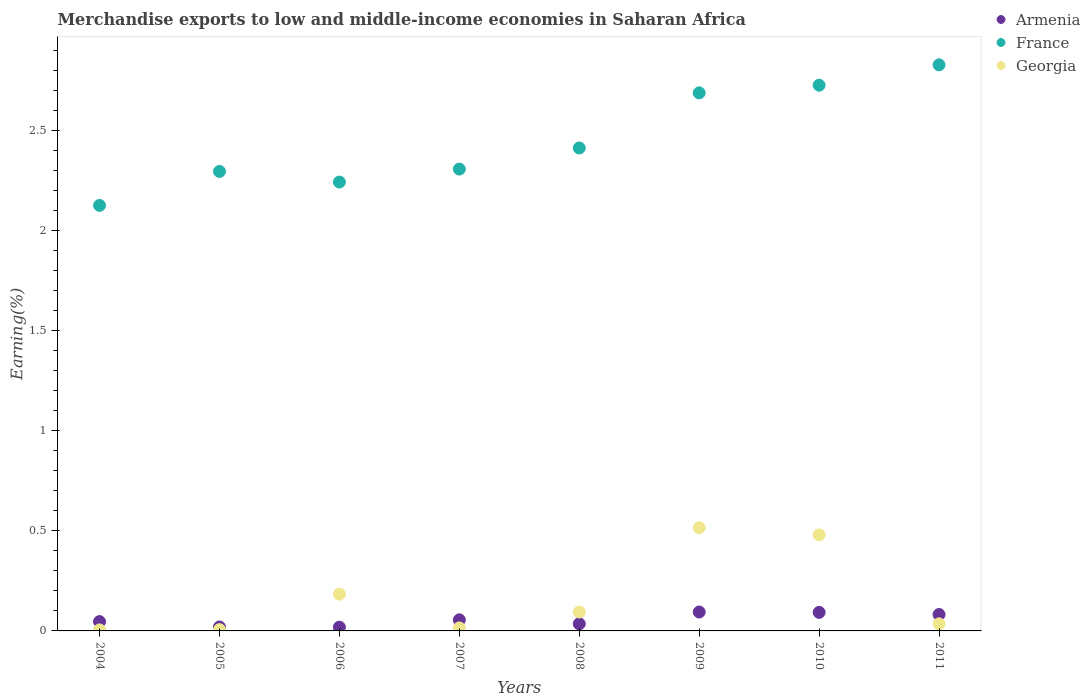Is the number of dotlines equal to the number of legend labels?
Provide a short and direct response. Yes. What is the percentage of amount earned from merchandise exports in Armenia in 2004?
Keep it short and to the point. 0.05. Across all years, what is the maximum percentage of amount earned from merchandise exports in Armenia?
Offer a very short reply. 0.09. Across all years, what is the minimum percentage of amount earned from merchandise exports in France?
Ensure brevity in your answer.  2.13. In which year was the percentage of amount earned from merchandise exports in Armenia minimum?
Make the answer very short. 2006. What is the total percentage of amount earned from merchandise exports in Georgia in the graph?
Your answer should be compact. 1.34. What is the difference between the percentage of amount earned from merchandise exports in Armenia in 2006 and that in 2011?
Ensure brevity in your answer.  -0.06. What is the difference between the percentage of amount earned from merchandise exports in Georgia in 2005 and the percentage of amount earned from merchandise exports in France in 2008?
Offer a very short reply. -2.41. What is the average percentage of amount earned from merchandise exports in Georgia per year?
Your answer should be very brief. 0.17. In the year 2007, what is the difference between the percentage of amount earned from merchandise exports in France and percentage of amount earned from merchandise exports in Armenia?
Offer a terse response. 2.25. What is the ratio of the percentage of amount earned from merchandise exports in Armenia in 2008 to that in 2009?
Ensure brevity in your answer.  0.38. Is the difference between the percentage of amount earned from merchandise exports in France in 2005 and 2011 greater than the difference between the percentage of amount earned from merchandise exports in Armenia in 2005 and 2011?
Offer a terse response. No. What is the difference between the highest and the second highest percentage of amount earned from merchandise exports in Armenia?
Offer a terse response. 0. What is the difference between the highest and the lowest percentage of amount earned from merchandise exports in Georgia?
Make the answer very short. 0.51. In how many years, is the percentage of amount earned from merchandise exports in France greater than the average percentage of amount earned from merchandise exports in France taken over all years?
Provide a short and direct response. 3. Is it the case that in every year, the sum of the percentage of amount earned from merchandise exports in France and percentage of amount earned from merchandise exports in Georgia  is greater than the percentage of amount earned from merchandise exports in Armenia?
Your answer should be compact. Yes. Does the percentage of amount earned from merchandise exports in Georgia monotonically increase over the years?
Offer a very short reply. No. Is the percentage of amount earned from merchandise exports in Armenia strictly less than the percentage of amount earned from merchandise exports in France over the years?
Ensure brevity in your answer.  Yes. Are the values on the major ticks of Y-axis written in scientific E-notation?
Your response must be concise. No. Does the graph contain any zero values?
Offer a terse response. No. How are the legend labels stacked?
Give a very brief answer. Vertical. What is the title of the graph?
Ensure brevity in your answer.  Merchandise exports to low and middle-income economies in Saharan Africa. What is the label or title of the Y-axis?
Offer a very short reply. Earning(%). What is the Earning(%) of Armenia in 2004?
Keep it short and to the point. 0.05. What is the Earning(%) of France in 2004?
Make the answer very short. 2.13. What is the Earning(%) of Georgia in 2004?
Your answer should be very brief. 0.01. What is the Earning(%) in Armenia in 2005?
Your response must be concise. 0.02. What is the Earning(%) in France in 2005?
Give a very brief answer. 2.3. What is the Earning(%) in Georgia in 2005?
Your response must be concise. 0.01. What is the Earning(%) in Armenia in 2006?
Ensure brevity in your answer.  0.02. What is the Earning(%) in France in 2006?
Give a very brief answer. 2.24. What is the Earning(%) of Georgia in 2006?
Your response must be concise. 0.18. What is the Earning(%) of Armenia in 2007?
Give a very brief answer. 0.06. What is the Earning(%) of France in 2007?
Offer a terse response. 2.31. What is the Earning(%) of Georgia in 2007?
Keep it short and to the point. 0.02. What is the Earning(%) of Armenia in 2008?
Give a very brief answer. 0.04. What is the Earning(%) in France in 2008?
Offer a terse response. 2.41. What is the Earning(%) of Georgia in 2008?
Provide a short and direct response. 0.09. What is the Earning(%) of Armenia in 2009?
Offer a terse response. 0.09. What is the Earning(%) of France in 2009?
Ensure brevity in your answer.  2.69. What is the Earning(%) in Georgia in 2009?
Your answer should be compact. 0.52. What is the Earning(%) of Armenia in 2010?
Provide a succinct answer. 0.09. What is the Earning(%) of France in 2010?
Offer a very short reply. 2.73. What is the Earning(%) of Georgia in 2010?
Offer a very short reply. 0.48. What is the Earning(%) of Armenia in 2011?
Offer a very short reply. 0.08. What is the Earning(%) of France in 2011?
Offer a terse response. 2.83. What is the Earning(%) of Georgia in 2011?
Your answer should be very brief. 0.04. Across all years, what is the maximum Earning(%) in Armenia?
Make the answer very short. 0.09. Across all years, what is the maximum Earning(%) in France?
Your answer should be very brief. 2.83. Across all years, what is the maximum Earning(%) in Georgia?
Offer a terse response. 0.52. Across all years, what is the minimum Earning(%) in Armenia?
Ensure brevity in your answer.  0.02. Across all years, what is the minimum Earning(%) in France?
Make the answer very short. 2.13. Across all years, what is the minimum Earning(%) of Georgia?
Provide a succinct answer. 0.01. What is the total Earning(%) of Armenia in the graph?
Your answer should be compact. 0.45. What is the total Earning(%) of France in the graph?
Offer a very short reply. 19.64. What is the total Earning(%) of Georgia in the graph?
Offer a terse response. 1.34. What is the difference between the Earning(%) of Armenia in 2004 and that in 2005?
Your answer should be very brief. 0.03. What is the difference between the Earning(%) of France in 2004 and that in 2005?
Provide a succinct answer. -0.17. What is the difference between the Earning(%) in Georgia in 2004 and that in 2005?
Your answer should be very brief. -0. What is the difference between the Earning(%) of Armenia in 2004 and that in 2006?
Your answer should be very brief. 0.03. What is the difference between the Earning(%) in France in 2004 and that in 2006?
Offer a very short reply. -0.12. What is the difference between the Earning(%) of Georgia in 2004 and that in 2006?
Your answer should be compact. -0.18. What is the difference between the Earning(%) of Armenia in 2004 and that in 2007?
Your answer should be very brief. -0.01. What is the difference between the Earning(%) of France in 2004 and that in 2007?
Ensure brevity in your answer.  -0.18. What is the difference between the Earning(%) of Georgia in 2004 and that in 2007?
Offer a terse response. -0.01. What is the difference between the Earning(%) in Armenia in 2004 and that in 2008?
Provide a succinct answer. 0.01. What is the difference between the Earning(%) in France in 2004 and that in 2008?
Keep it short and to the point. -0.29. What is the difference between the Earning(%) in Georgia in 2004 and that in 2008?
Provide a short and direct response. -0.09. What is the difference between the Earning(%) in Armenia in 2004 and that in 2009?
Give a very brief answer. -0.05. What is the difference between the Earning(%) in France in 2004 and that in 2009?
Offer a very short reply. -0.56. What is the difference between the Earning(%) of Georgia in 2004 and that in 2009?
Provide a short and direct response. -0.51. What is the difference between the Earning(%) of Armenia in 2004 and that in 2010?
Your answer should be very brief. -0.05. What is the difference between the Earning(%) in France in 2004 and that in 2010?
Provide a short and direct response. -0.6. What is the difference between the Earning(%) of Georgia in 2004 and that in 2010?
Your answer should be compact. -0.48. What is the difference between the Earning(%) in Armenia in 2004 and that in 2011?
Keep it short and to the point. -0.04. What is the difference between the Earning(%) in France in 2004 and that in 2011?
Provide a succinct answer. -0.7. What is the difference between the Earning(%) of Georgia in 2004 and that in 2011?
Offer a very short reply. -0.03. What is the difference between the Earning(%) of Armenia in 2005 and that in 2006?
Your answer should be compact. 0. What is the difference between the Earning(%) in France in 2005 and that in 2006?
Keep it short and to the point. 0.05. What is the difference between the Earning(%) in Georgia in 2005 and that in 2006?
Your answer should be very brief. -0.18. What is the difference between the Earning(%) of Armenia in 2005 and that in 2007?
Your answer should be very brief. -0.04. What is the difference between the Earning(%) in France in 2005 and that in 2007?
Make the answer very short. -0.01. What is the difference between the Earning(%) of Georgia in 2005 and that in 2007?
Keep it short and to the point. -0.01. What is the difference between the Earning(%) in Armenia in 2005 and that in 2008?
Your response must be concise. -0.02. What is the difference between the Earning(%) of France in 2005 and that in 2008?
Your answer should be compact. -0.12. What is the difference between the Earning(%) of Georgia in 2005 and that in 2008?
Make the answer very short. -0.09. What is the difference between the Earning(%) of Armenia in 2005 and that in 2009?
Give a very brief answer. -0.07. What is the difference between the Earning(%) of France in 2005 and that in 2009?
Offer a terse response. -0.39. What is the difference between the Earning(%) of Georgia in 2005 and that in 2009?
Your answer should be compact. -0.51. What is the difference between the Earning(%) in Armenia in 2005 and that in 2010?
Make the answer very short. -0.07. What is the difference between the Earning(%) of France in 2005 and that in 2010?
Your answer should be very brief. -0.43. What is the difference between the Earning(%) of Georgia in 2005 and that in 2010?
Keep it short and to the point. -0.47. What is the difference between the Earning(%) of Armenia in 2005 and that in 2011?
Provide a short and direct response. -0.06. What is the difference between the Earning(%) of France in 2005 and that in 2011?
Keep it short and to the point. -0.53. What is the difference between the Earning(%) in Georgia in 2005 and that in 2011?
Offer a terse response. -0.03. What is the difference between the Earning(%) of Armenia in 2006 and that in 2007?
Offer a terse response. -0.04. What is the difference between the Earning(%) of France in 2006 and that in 2007?
Your answer should be very brief. -0.06. What is the difference between the Earning(%) of Georgia in 2006 and that in 2007?
Provide a short and direct response. 0.17. What is the difference between the Earning(%) of Armenia in 2006 and that in 2008?
Keep it short and to the point. -0.02. What is the difference between the Earning(%) of France in 2006 and that in 2008?
Your answer should be very brief. -0.17. What is the difference between the Earning(%) of Georgia in 2006 and that in 2008?
Ensure brevity in your answer.  0.09. What is the difference between the Earning(%) in Armenia in 2006 and that in 2009?
Your answer should be compact. -0.08. What is the difference between the Earning(%) in France in 2006 and that in 2009?
Give a very brief answer. -0.45. What is the difference between the Earning(%) in Georgia in 2006 and that in 2009?
Your response must be concise. -0.33. What is the difference between the Earning(%) in Armenia in 2006 and that in 2010?
Your response must be concise. -0.07. What is the difference between the Earning(%) in France in 2006 and that in 2010?
Keep it short and to the point. -0.48. What is the difference between the Earning(%) in Georgia in 2006 and that in 2010?
Make the answer very short. -0.3. What is the difference between the Earning(%) in Armenia in 2006 and that in 2011?
Your response must be concise. -0.06. What is the difference between the Earning(%) in France in 2006 and that in 2011?
Give a very brief answer. -0.59. What is the difference between the Earning(%) in Georgia in 2006 and that in 2011?
Give a very brief answer. 0.15. What is the difference between the Earning(%) in Armenia in 2007 and that in 2008?
Your answer should be compact. 0.02. What is the difference between the Earning(%) in France in 2007 and that in 2008?
Keep it short and to the point. -0.11. What is the difference between the Earning(%) in Georgia in 2007 and that in 2008?
Offer a terse response. -0.08. What is the difference between the Earning(%) in Armenia in 2007 and that in 2009?
Offer a very short reply. -0.04. What is the difference between the Earning(%) in France in 2007 and that in 2009?
Your answer should be compact. -0.38. What is the difference between the Earning(%) in Georgia in 2007 and that in 2009?
Make the answer very short. -0.5. What is the difference between the Earning(%) in Armenia in 2007 and that in 2010?
Give a very brief answer. -0.04. What is the difference between the Earning(%) of France in 2007 and that in 2010?
Provide a short and direct response. -0.42. What is the difference between the Earning(%) in Georgia in 2007 and that in 2010?
Make the answer very short. -0.47. What is the difference between the Earning(%) of Armenia in 2007 and that in 2011?
Offer a terse response. -0.03. What is the difference between the Earning(%) in France in 2007 and that in 2011?
Give a very brief answer. -0.52. What is the difference between the Earning(%) in Georgia in 2007 and that in 2011?
Keep it short and to the point. -0.02. What is the difference between the Earning(%) in Armenia in 2008 and that in 2009?
Offer a very short reply. -0.06. What is the difference between the Earning(%) in France in 2008 and that in 2009?
Provide a succinct answer. -0.28. What is the difference between the Earning(%) in Georgia in 2008 and that in 2009?
Offer a very short reply. -0.42. What is the difference between the Earning(%) of Armenia in 2008 and that in 2010?
Ensure brevity in your answer.  -0.06. What is the difference between the Earning(%) of France in 2008 and that in 2010?
Your answer should be very brief. -0.31. What is the difference between the Earning(%) in Georgia in 2008 and that in 2010?
Your answer should be compact. -0.39. What is the difference between the Earning(%) in Armenia in 2008 and that in 2011?
Give a very brief answer. -0.05. What is the difference between the Earning(%) in France in 2008 and that in 2011?
Your response must be concise. -0.42. What is the difference between the Earning(%) of Georgia in 2008 and that in 2011?
Provide a short and direct response. 0.06. What is the difference between the Earning(%) of Armenia in 2009 and that in 2010?
Your answer should be very brief. 0. What is the difference between the Earning(%) of France in 2009 and that in 2010?
Ensure brevity in your answer.  -0.04. What is the difference between the Earning(%) in Georgia in 2009 and that in 2010?
Offer a terse response. 0.04. What is the difference between the Earning(%) in Armenia in 2009 and that in 2011?
Offer a very short reply. 0.01. What is the difference between the Earning(%) in France in 2009 and that in 2011?
Ensure brevity in your answer.  -0.14. What is the difference between the Earning(%) in Georgia in 2009 and that in 2011?
Provide a short and direct response. 0.48. What is the difference between the Earning(%) in Armenia in 2010 and that in 2011?
Provide a succinct answer. 0.01. What is the difference between the Earning(%) in France in 2010 and that in 2011?
Provide a short and direct response. -0.1. What is the difference between the Earning(%) in Georgia in 2010 and that in 2011?
Your answer should be compact. 0.44. What is the difference between the Earning(%) in Armenia in 2004 and the Earning(%) in France in 2005?
Your answer should be compact. -2.25. What is the difference between the Earning(%) of Armenia in 2004 and the Earning(%) of Georgia in 2005?
Your response must be concise. 0.04. What is the difference between the Earning(%) in France in 2004 and the Earning(%) in Georgia in 2005?
Your answer should be compact. 2.12. What is the difference between the Earning(%) of Armenia in 2004 and the Earning(%) of France in 2006?
Your answer should be compact. -2.2. What is the difference between the Earning(%) in Armenia in 2004 and the Earning(%) in Georgia in 2006?
Provide a short and direct response. -0.14. What is the difference between the Earning(%) of France in 2004 and the Earning(%) of Georgia in 2006?
Make the answer very short. 1.94. What is the difference between the Earning(%) in Armenia in 2004 and the Earning(%) in France in 2007?
Keep it short and to the point. -2.26. What is the difference between the Earning(%) in Armenia in 2004 and the Earning(%) in Georgia in 2007?
Give a very brief answer. 0.03. What is the difference between the Earning(%) of France in 2004 and the Earning(%) of Georgia in 2007?
Provide a short and direct response. 2.11. What is the difference between the Earning(%) of Armenia in 2004 and the Earning(%) of France in 2008?
Your answer should be very brief. -2.37. What is the difference between the Earning(%) in Armenia in 2004 and the Earning(%) in Georgia in 2008?
Give a very brief answer. -0.05. What is the difference between the Earning(%) in France in 2004 and the Earning(%) in Georgia in 2008?
Keep it short and to the point. 2.03. What is the difference between the Earning(%) in Armenia in 2004 and the Earning(%) in France in 2009?
Your answer should be compact. -2.64. What is the difference between the Earning(%) of Armenia in 2004 and the Earning(%) of Georgia in 2009?
Offer a terse response. -0.47. What is the difference between the Earning(%) in France in 2004 and the Earning(%) in Georgia in 2009?
Offer a terse response. 1.61. What is the difference between the Earning(%) of Armenia in 2004 and the Earning(%) of France in 2010?
Provide a succinct answer. -2.68. What is the difference between the Earning(%) in Armenia in 2004 and the Earning(%) in Georgia in 2010?
Provide a short and direct response. -0.43. What is the difference between the Earning(%) of France in 2004 and the Earning(%) of Georgia in 2010?
Provide a short and direct response. 1.65. What is the difference between the Earning(%) of Armenia in 2004 and the Earning(%) of France in 2011?
Ensure brevity in your answer.  -2.78. What is the difference between the Earning(%) of Armenia in 2004 and the Earning(%) of Georgia in 2011?
Offer a very short reply. 0.01. What is the difference between the Earning(%) of France in 2004 and the Earning(%) of Georgia in 2011?
Make the answer very short. 2.09. What is the difference between the Earning(%) of Armenia in 2005 and the Earning(%) of France in 2006?
Make the answer very short. -2.22. What is the difference between the Earning(%) of Armenia in 2005 and the Earning(%) of Georgia in 2006?
Keep it short and to the point. -0.16. What is the difference between the Earning(%) in France in 2005 and the Earning(%) in Georgia in 2006?
Provide a short and direct response. 2.11. What is the difference between the Earning(%) in Armenia in 2005 and the Earning(%) in France in 2007?
Your response must be concise. -2.29. What is the difference between the Earning(%) in Armenia in 2005 and the Earning(%) in Georgia in 2007?
Provide a short and direct response. 0. What is the difference between the Earning(%) in France in 2005 and the Earning(%) in Georgia in 2007?
Provide a short and direct response. 2.28. What is the difference between the Earning(%) of Armenia in 2005 and the Earning(%) of France in 2008?
Ensure brevity in your answer.  -2.4. What is the difference between the Earning(%) in Armenia in 2005 and the Earning(%) in Georgia in 2008?
Provide a succinct answer. -0.08. What is the difference between the Earning(%) of France in 2005 and the Earning(%) of Georgia in 2008?
Provide a short and direct response. 2.2. What is the difference between the Earning(%) in Armenia in 2005 and the Earning(%) in France in 2009?
Your answer should be very brief. -2.67. What is the difference between the Earning(%) of Armenia in 2005 and the Earning(%) of Georgia in 2009?
Give a very brief answer. -0.5. What is the difference between the Earning(%) in France in 2005 and the Earning(%) in Georgia in 2009?
Your response must be concise. 1.78. What is the difference between the Earning(%) in Armenia in 2005 and the Earning(%) in France in 2010?
Ensure brevity in your answer.  -2.71. What is the difference between the Earning(%) of Armenia in 2005 and the Earning(%) of Georgia in 2010?
Your answer should be compact. -0.46. What is the difference between the Earning(%) in France in 2005 and the Earning(%) in Georgia in 2010?
Your answer should be very brief. 1.82. What is the difference between the Earning(%) of Armenia in 2005 and the Earning(%) of France in 2011?
Keep it short and to the point. -2.81. What is the difference between the Earning(%) of Armenia in 2005 and the Earning(%) of Georgia in 2011?
Give a very brief answer. -0.02. What is the difference between the Earning(%) in France in 2005 and the Earning(%) in Georgia in 2011?
Your answer should be compact. 2.26. What is the difference between the Earning(%) in Armenia in 2006 and the Earning(%) in France in 2007?
Keep it short and to the point. -2.29. What is the difference between the Earning(%) of Armenia in 2006 and the Earning(%) of Georgia in 2007?
Keep it short and to the point. 0. What is the difference between the Earning(%) of France in 2006 and the Earning(%) of Georgia in 2007?
Your answer should be compact. 2.23. What is the difference between the Earning(%) in Armenia in 2006 and the Earning(%) in France in 2008?
Provide a short and direct response. -2.4. What is the difference between the Earning(%) of Armenia in 2006 and the Earning(%) of Georgia in 2008?
Your response must be concise. -0.08. What is the difference between the Earning(%) in France in 2006 and the Earning(%) in Georgia in 2008?
Provide a succinct answer. 2.15. What is the difference between the Earning(%) of Armenia in 2006 and the Earning(%) of France in 2009?
Keep it short and to the point. -2.67. What is the difference between the Earning(%) in Armenia in 2006 and the Earning(%) in Georgia in 2009?
Your answer should be compact. -0.5. What is the difference between the Earning(%) in France in 2006 and the Earning(%) in Georgia in 2009?
Your answer should be very brief. 1.73. What is the difference between the Earning(%) in Armenia in 2006 and the Earning(%) in France in 2010?
Give a very brief answer. -2.71. What is the difference between the Earning(%) of Armenia in 2006 and the Earning(%) of Georgia in 2010?
Your answer should be compact. -0.46. What is the difference between the Earning(%) of France in 2006 and the Earning(%) of Georgia in 2010?
Your answer should be compact. 1.76. What is the difference between the Earning(%) of Armenia in 2006 and the Earning(%) of France in 2011?
Your answer should be compact. -2.81. What is the difference between the Earning(%) in Armenia in 2006 and the Earning(%) in Georgia in 2011?
Offer a very short reply. -0.02. What is the difference between the Earning(%) of France in 2006 and the Earning(%) of Georgia in 2011?
Give a very brief answer. 2.21. What is the difference between the Earning(%) in Armenia in 2007 and the Earning(%) in France in 2008?
Offer a very short reply. -2.36. What is the difference between the Earning(%) of Armenia in 2007 and the Earning(%) of Georgia in 2008?
Offer a terse response. -0.04. What is the difference between the Earning(%) in France in 2007 and the Earning(%) in Georgia in 2008?
Your answer should be compact. 2.21. What is the difference between the Earning(%) of Armenia in 2007 and the Earning(%) of France in 2009?
Provide a short and direct response. -2.63. What is the difference between the Earning(%) of Armenia in 2007 and the Earning(%) of Georgia in 2009?
Provide a succinct answer. -0.46. What is the difference between the Earning(%) in France in 2007 and the Earning(%) in Georgia in 2009?
Provide a short and direct response. 1.79. What is the difference between the Earning(%) in Armenia in 2007 and the Earning(%) in France in 2010?
Provide a short and direct response. -2.67. What is the difference between the Earning(%) in Armenia in 2007 and the Earning(%) in Georgia in 2010?
Ensure brevity in your answer.  -0.42. What is the difference between the Earning(%) of France in 2007 and the Earning(%) of Georgia in 2010?
Make the answer very short. 1.83. What is the difference between the Earning(%) in Armenia in 2007 and the Earning(%) in France in 2011?
Ensure brevity in your answer.  -2.78. What is the difference between the Earning(%) in Armenia in 2007 and the Earning(%) in Georgia in 2011?
Give a very brief answer. 0.02. What is the difference between the Earning(%) in France in 2007 and the Earning(%) in Georgia in 2011?
Keep it short and to the point. 2.27. What is the difference between the Earning(%) of Armenia in 2008 and the Earning(%) of France in 2009?
Make the answer very short. -2.65. What is the difference between the Earning(%) of Armenia in 2008 and the Earning(%) of Georgia in 2009?
Your answer should be compact. -0.48. What is the difference between the Earning(%) of France in 2008 and the Earning(%) of Georgia in 2009?
Ensure brevity in your answer.  1.9. What is the difference between the Earning(%) of Armenia in 2008 and the Earning(%) of France in 2010?
Ensure brevity in your answer.  -2.69. What is the difference between the Earning(%) in Armenia in 2008 and the Earning(%) in Georgia in 2010?
Your answer should be very brief. -0.44. What is the difference between the Earning(%) of France in 2008 and the Earning(%) of Georgia in 2010?
Your response must be concise. 1.93. What is the difference between the Earning(%) of Armenia in 2008 and the Earning(%) of France in 2011?
Keep it short and to the point. -2.79. What is the difference between the Earning(%) in France in 2008 and the Earning(%) in Georgia in 2011?
Provide a short and direct response. 2.38. What is the difference between the Earning(%) in Armenia in 2009 and the Earning(%) in France in 2010?
Make the answer very short. -2.63. What is the difference between the Earning(%) in Armenia in 2009 and the Earning(%) in Georgia in 2010?
Your answer should be compact. -0.39. What is the difference between the Earning(%) in France in 2009 and the Earning(%) in Georgia in 2010?
Ensure brevity in your answer.  2.21. What is the difference between the Earning(%) in Armenia in 2009 and the Earning(%) in France in 2011?
Offer a very short reply. -2.74. What is the difference between the Earning(%) of Armenia in 2009 and the Earning(%) of Georgia in 2011?
Ensure brevity in your answer.  0.06. What is the difference between the Earning(%) of France in 2009 and the Earning(%) of Georgia in 2011?
Your response must be concise. 2.65. What is the difference between the Earning(%) in Armenia in 2010 and the Earning(%) in France in 2011?
Provide a succinct answer. -2.74. What is the difference between the Earning(%) in Armenia in 2010 and the Earning(%) in Georgia in 2011?
Offer a terse response. 0.06. What is the difference between the Earning(%) of France in 2010 and the Earning(%) of Georgia in 2011?
Make the answer very short. 2.69. What is the average Earning(%) of Armenia per year?
Ensure brevity in your answer.  0.06. What is the average Earning(%) of France per year?
Keep it short and to the point. 2.46. What is the average Earning(%) of Georgia per year?
Provide a short and direct response. 0.17. In the year 2004, what is the difference between the Earning(%) in Armenia and Earning(%) in France?
Your answer should be compact. -2.08. In the year 2004, what is the difference between the Earning(%) in Armenia and Earning(%) in Georgia?
Your answer should be compact. 0.04. In the year 2004, what is the difference between the Earning(%) of France and Earning(%) of Georgia?
Offer a terse response. 2.12. In the year 2005, what is the difference between the Earning(%) of Armenia and Earning(%) of France?
Keep it short and to the point. -2.28. In the year 2005, what is the difference between the Earning(%) of Armenia and Earning(%) of Georgia?
Your answer should be very brief. 0.01. In the year 2005, what is the difference between the Earning(%) in France and Earning(%) in Georgia?
Make the answer very short. 2.29. In the year 2006, what is the difference between the Earning(%) of Armenia and Earning(%) of France?
Your answer should be very brief. -2.23. In the year 2006, what is the difference between the Earning(%) in Armenia and Earning(%) in Georgia?
Offer a very short reply. -0.17. In the year 2006, what is the difference between the Earning(%) in France and Earning(%) in Georgia?
Offer a terse response. 2.06. In the year 2007, what is the difference between the Earning(%) of Armenia and Earning(%) of France?
Provide a short and direct response. -2.25. In the year 2007, what is the difference between the Earning(%) of Armenia and Earning(%) of Georgia?
Your answer should be very brief. 0.04. In the year 2007, what is the difference between the Earning(%) of France and Earning(%) of Georgia?
Offer a terse response. 2.29. In the year 2008, what is the difference between the Earning(%) in Armenia and Earning(%) in France?
Give a very brief answer. -2.38. In the year 2008, what is the difference between the Earning(%) of Armenia and Earning(%) of Georgia?
Provide a succinct answer. -0.06. In the year 2008, what is the difference between the Earning(%) in France and Earning(%) in Georgia?
Offer a terse response. 2.32. In the year 2009, what is the difference between the Earning(%) of Armenia and Earning(%) of France?
Give a very brief answer. -2.6. In the year 2009, what is the difference between the Earning(%) of Armenia and Earning(%) of Georgia?
Provide a short and direct response. -0.42. In the year 2009, what is the difference between the Earning(%) of France and Earning(%) of Georgia?
Give a very brief answer. 2.17. In the year 2010, what is the difference between the Earning(%) in Armenia and Earning(%) in France?
Your response must be concise. -2.64. In the year 2010, what is the difference between the Earning(%) in Armenia and Earning(%) in Georgia?
Offer a very short reply. -0.39. In the year 2010, what is the difference between the Earning(%) of France and Earning(%) of Georgia?
Make the answer very short. 2.25. In the year 2011, what is the difference between the Earning(%) of Armenia and Earning(%) of France?
Make the answer very short. -2.75. In the year 2011, what is the difference between the Earning(%) of Armenia and Earning(%) of Georgia?
Make the answer very short. 0.05. In the year 2011, what is the difference between the Earning(%) in France and Earning(%) in Georgia?
Provide a short and direct response. 2.79. What is the ratio of the Earning(%) in Armenia in 2004 to that in 2005?
Your answer should be very brief. 2.38. What is the ratio of the Earning(%) in France in 2004 to that in 2005?
Keep it short and to the point. 0.93. What is the ratio of the Earning(%) of Georgia in 2004 to that in 2005?
Offer a terse response. 0.78. What is the ratio of the Earning(%) of Armenia in 2004 to that in 2006?
Provide a short and direct response. 2.49. What is the ratio of the Earning(%) in France in 2004 to that in 2006?
Provide a succinct answer. 0.95. What is the ratio of the Earning(%) of Georgia in 2004 to that in 2006?
Ensure brevity in your answer.  0.03. What is the ratio of the Earning(%) of Armenia in 2004 to that in 2007?
Offer a very short reply. 0.84. What is the ratio of the Earning(%) of France in 2004 to that in 2007?
Your answer should be compact. 0.92. What is the ratio of the Earning(%) of Georgia in 2004 to that in 2007?
Your response must be concise. 0.33. What is the ratio of the Earning(%) of Armenia in 2004 to that in 2008?
Give a very brief answer. 1.31. What is the ratio of the Earning(%) of France in 2004 to that in 2008?
Give a very brief answer. 0.88. What is the ratio of the Earning(%) of Georgia in 2004 to that in 2008?
Your answer should be very brief. 0.05. What is the ratio of the Earning(%) in Armenia in 2004 to that in 2009?
Offer a terse response. 0.49. What is the ratio of the Earning(%) of France in 2004 to that in 2009?
Offer a very short reply. 0.79. What is the ratio of the Earning(%) of Georgia in 2004 to that in 2009?
Your response must be concise. 0.01. What is the ratio of the Earning(%) in Armenia in 2004 to that in 2010?
Give a very brief answer. 0.5. What is the ratio of the Earning(%) in France in 2004 to that in 2010?
Keep it short and to the point. 0.78. What is the ratio of the Earning(%) in Georgia in 2004 to that in 2010?
Provide a short and direct response. 0.01. What is the ratio of the Earning(%) in Armenia in 2004 to that in 2011?
Make the answer very short. 0.57. What is the ratio of the Earning(%) of France in 2004 to that in 2011?
Make the answer very short. 0.75. What is the ratio of the Earning(%) in Georgia in 2004 to that in 2011?
Offer a terse response. 0.14. What is the ratio of the Earning(%) in Armenia in 2005 to that in 2006?
Provide a short and direct response. 1.05. What is the ratio of the Earning(%) in France in 2005 to that in 2006?
Your answer should be very brief. 1.02. What is the ratio of the Earning(%) in Georgia in 2005 to that in 2006?
Give a very brief answer. 0.04. What is the ratio of the Earning(%) of Armenia in 2005 to that in 2007?
Keep it short and to the point. 0.35. What is the ratio of the Earning(%) in Georgia in 2005 to that in 2007?
Offer a terse response. 0.43. What is the ratio of the Earning(%) of Armenia in 2005 to that in 2008?
Provide a succinct answer. 0.55. What is the ratio of the Earning(%) of France in 2005 to that in 2008?
Offer a terse response. 0.95. What is the ratio of the Earning(%) of Georgia in 2005 to that in 2008?
Make the answer very short. 0.07. What is the ratio of the Earning(%) in Armenia in 2005 to that in 2009?
Your response must be concise. 0.21. What is the ratio of the Earning(%) in France in 2005 to that in 2009?
Keep it short and to the point. 0.85. What is the ratio of the Earning(%) in Georgia in 2005 to that in 2009?
Your answer should be very brief. 0.01. What is the ratio of the Earning(%) in Armenia in 2005 to that in 2010?
Provide a short and direct response. 0.21. What is the ratio of the Earning(%) of France in 2005 to that in 2010?
Keep it short and to the point. 0.84. What is the ratio of the Earning(%) in Georgia in 2005 to that in 2010?
Provide a short and direct response. 0.01. What is the ratio of the Earning(%) of Armenia in 2005 to that in 2011?
Ensure brevity in your answer.  0.24. What is the ratio of the Earning(%) in France in 2005 to that in 2011?
Keep it short and to the point. 0.81. What is the ratio of the Earning(%) in Georgia in 2005 to that in 2011?
Provide a succinct answer. 0.18. What is the ratio of the Earning(%) of Armenia in 2006 to that in 2007?
Offer a terse response. 0.34. What is the ratio of the Earning(%) in France in 2006 to that in 2007?
Ensure brevity in your answer.  0.97. What is the ratio of the Earning(%) of Georgia in 2006 to that in 2007?
Your answer should be very brief. 12.21. What is the ratio of the Earning(%) in Armenia in 2006 to that in 2008?
Provide a succinct answer. 0.53. What is the ratio of the Earning(%) of France in 2006 to that in 2008?
Ensure brevity in your answer.  0.93. What is the ratio of the Earning(%) of Georgia in 2006 to that in 2008?
Offer a terse response. 1.94. What is the ratio of the Earning(%) in Armenia in 2006 to that in 2009?
Ensure brevity in your answer.  0.2. What is the ratio of the Earning(%) of France in 2006 to that in 2009?
Keep it short and to the point. 0.83. What is the ratio of the Earning(%) in Georgia in 2006 to that in 2009?
Provide a succinct answer. 0.36. What is the ratio of the Earning(%) of Armenia in 2006 to that in 2010?
Ensure brevity in your answer.  0.2. What is the ratio of the Earning(%) in France in 2006 to that in 2010?
Offer a very short reply. 0.82. What is the ratio of the Earning(%) in Georgia in 2006 to that in 2010?
Your response must be concise. 0.38. What is the ratio of the Earning(%) of Armenia in 2006 to that in 2011?
Provide a short and direct response. 0.23. What is the ratio of the Earning(%) in France in 2006 to that in 2011?
Your response must be concise. 0.79. What is the ratio of the Earning(%) in Georgia in 2006 to that in 2011?
Your answer should be compact. 5.17. What is the ratio of the Earning(%) of Armenia in 2007 to that in 2008?
Your response must be concise. 1.55. What is the ratio of the Earning(%) of France in 2007 to that in 2008?
Ensure brevity in your answer.  0.96. What is the ratio of the Earning(%) of Georgia in 2007 to that in 2008?
Offer a very short reply. 0.16. What is the ratio of the Earning(%) of Armenia in 2007 to that in 2009?
Your answer should be very brief. 0.59. What is the ratio of the Earning(%) in France in 2007 to that in 2009?
Your answer should be compact. 0.86. What is the ratio of the Earning(%) of Georgia in 2007 to that in 2009?
Your response must be concise. 0.03. What is the ratio of the Earning(%) in Armenia in 2007 to that in 2010?
Offer a very short reply. 0.6. What is the ratio of the Earning(%) of France in 2007 to that in 2010?
Keep it short and to the point. 0.85. What is the ratio of the Earning(%) in Georgia in 2007 to that in 2010?
Make the answer very short. 0.03. What is the ratio of the Earning(%) of Armenia in 2007 to that in 2011?
Keep it short and to the point. 0.68. What is the ratio of the Earning(%) of France in 2007 to that in 2011?
Ensure brevity in your answer.  0.82. What is the ratio of the Earning(%) of Georgia in 2007 to that in 2011?
Give a very brief answer. 0.42. What is the ratio of the Earning(%) of Armenia in 2008 to that in 2009?
Provide a succinct answer. 0.38. What is the ratio of the Earning(%) in France in 2008 to that in 2009?
Provide a succinct answer. 0.9. What is the ratio of the Earning(%) of Georgia in 2008 to that in 2009?
Keep it short and to the point. 0.18. What is the ratio of the Earning(%) of Armenia in 2008 to that in 2010?
Give a very brief answer. 0.39. What is the ratio of the Earning(%) of France in 2008 to that in 2010?
Ensure brevity in your answer.  0.88. What is the ratio of the Earning(%) in Georgia in 2008 to that in 2010?
Give a very brief answer. 0.2. What is the ratio of the Earning(%) of Armenia in 2008 to that in 2011?
Give a very brief answer. 0.44. What is the ratio of the Earning(%) of France in 2008 to that in 2011?
Offer a terse response. 0.85. What is the ratio of the Earning(%) of Georgia in 2008 to that in 2011?
Your answer should be very brief. 2.67. What is the ratio of the Earning(%) of Armenia in 2009 to that in 2010?
Provide a short and direct response. 1.02. What is the ratio of the Earning(%) in France in 2009 to that in 2010?
Provide a succinct answer. 0.99. What is the ratio of the Earning(%) of Georgia in 2009 to that in 2010?
Give a very brief answer. 1.07. What is the ratio of the Earning(%) in Armenia in 2009 to that in 2011?
Offer a very short reply. 1.15. What is the ratio of the Earning(%) of France in 2009 to that in 2011?
Provide a succinct answer. 0.95. What is the ratio of the Earning(%) of Georgia in 2009 to that in 2011?
Offer a terse response. 14.51. What is the ratio of the Earning(%) in Armenia in 2010 to that in 2011?
Keep it short and to the point. 1.13. What is the ratio of the Earning(%) of France in 2010 to that in 2011?
Provide a short and direct response. 0.96. What is the ratio of the Earning(%) in Georgia in 2010 to that in 2011?
Ensure brevity in your answer.  13.51. What is the difference between the highest and the second highest Earning(%) of Armenia?
Make the answer very short. 0. What is the difference between the highest and the second highest Earning(%) of France?
Give a very brief answer. 0.1. What is the difference between the highest and the second highest Earning(%) of Georgia?
Offer a terse response. 0.04. What is the difference between the highest and the lowest Earning(%) in Armenia?
Your answer should be compact. 0.08. What is the difference between the highest and the lowest Earning(%) in France?
Ensure brevity in your answer.  0.7. What is the difference between the highest and the lowest Earning(%) of Georgia?
Your answer should be very brief. 0.51. 